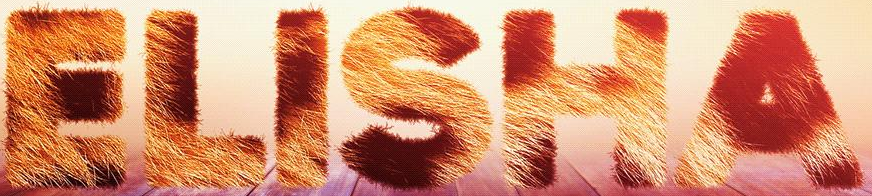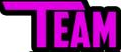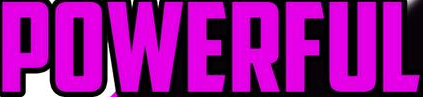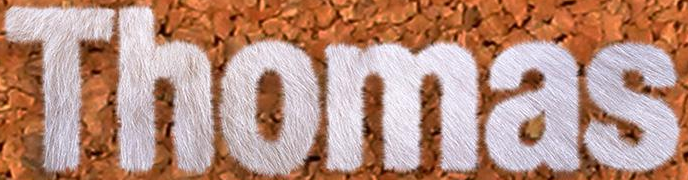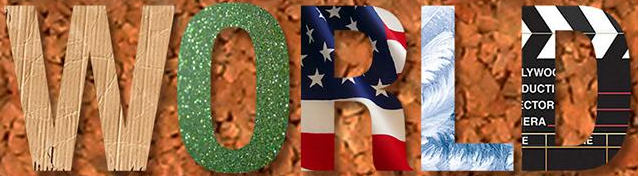Transcribe the words shown in these images in order, separated by a semicolon. ELISHA; TEAM; POWERFUL; Thomas; WORLD 